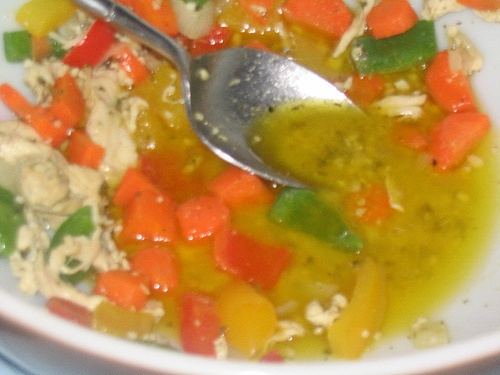Describe the objects in this image and their specific colors. I can see bowl in red, olive, lightgray, and orange tones, bowl in lightgray, tan, and darkgray tones, spoon in lightgray, gray, white, and darkgray tones, carrot in lightgray, red, and salmon tones, and carrot in lightgray, red, and salmon tones in this image. 